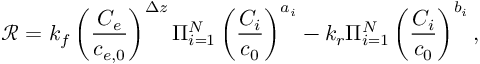Convert formula to latex. <formula><loc_0><loc_0><loc_500><loc_500>\mathcal { R } = k _ { f } \left ( \frac { C _ { e } } { c _ { e , 0 } } \right ) ^ { \Delta z } \Pi _ { i = 1 } ^ { N } \left ( \frac { C _ { i } } { c _ { 0 } } \right ) ^ { a _ { i } } - k _ { r } \Pi _ { i = 1 } ^ { N } \left ( \frac { C _ { i } } { c _ { 0 } } \right ) ^ { b _ { i } } ,</formula> 